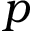Convert formula to latex. <formula><loc_0><loc_0><loc_500><loc_500>p</formula> 